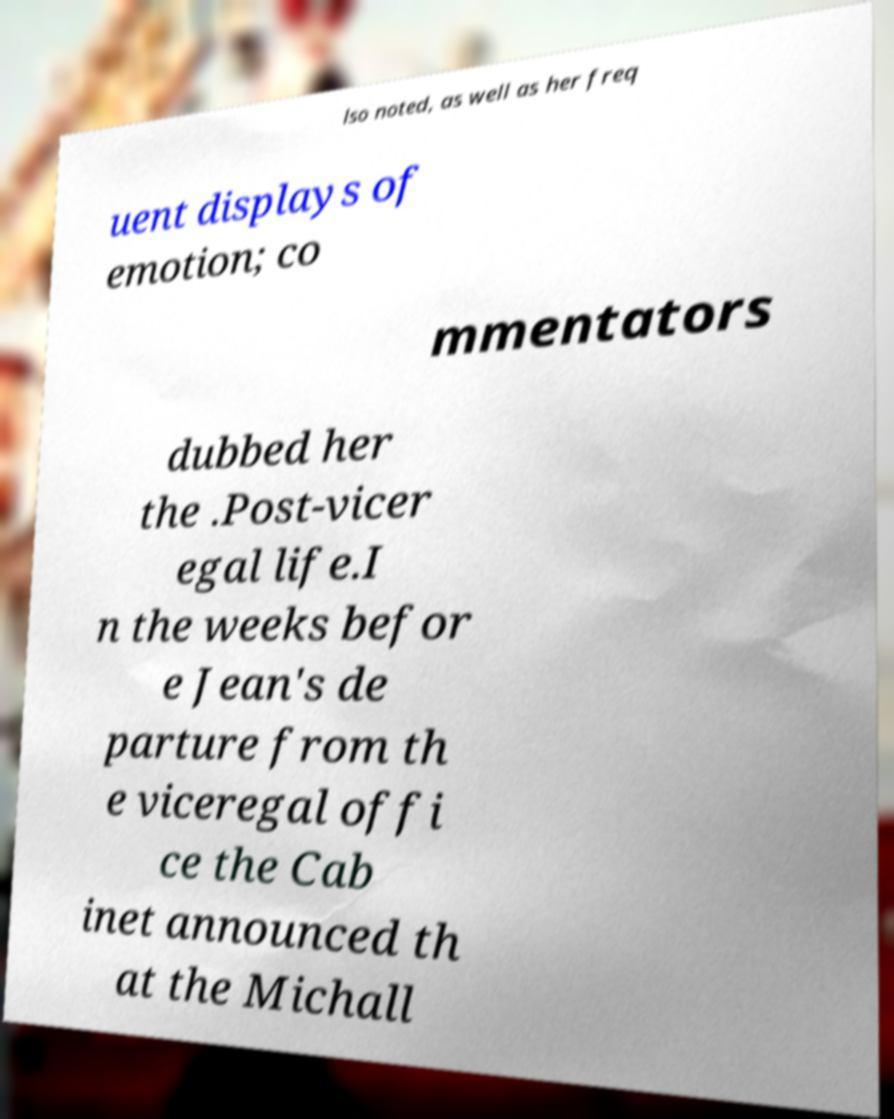What messages or text are displayed in this image? I need them in a readable, typed format. lso noted, as well as her freq uent displays of emotion; co mmentators dubbed her the .Post-vicer egal life.I n the weeks befor e Jean's de parture from th e viceregal offi ce the Cab inet announced th at the Michall 